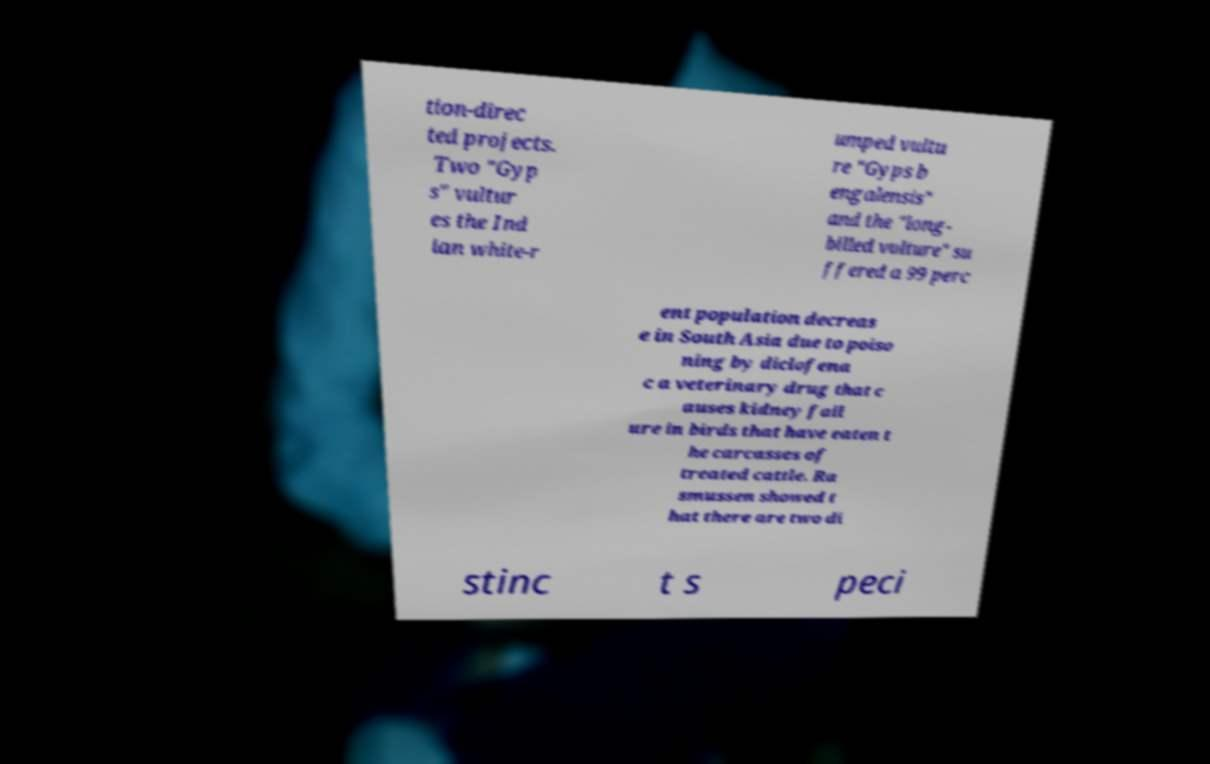I need the written content from this picture converted into text. Can you do that? tion-direc ted projects. Two "Gyp s" vultur es the Ind ian white-r umped vultu re "Gyps b engalensis" and the "long- billed vulture" su ffered a 99 perc ent population decreas e in South Asia due to poiso ning by diclofena c a veterinary drug that c auses kidney fail ure in birds that have eaten t he carcasses of treated cattle. Ra smussen showed t hat there are two di stinc t s peci 